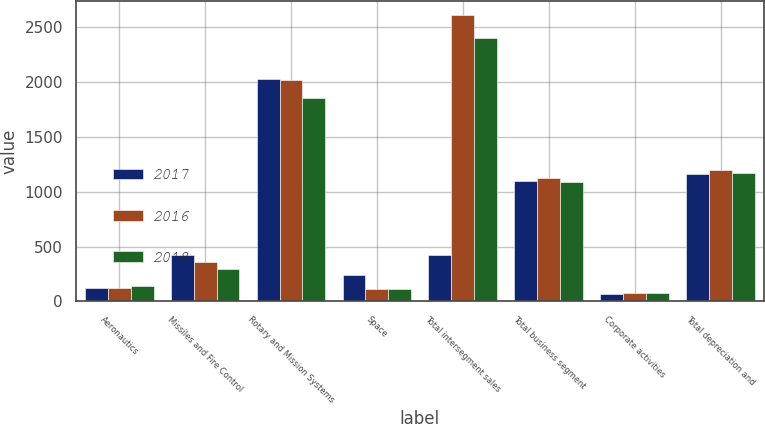Convert chart to OTSL. <chart><loc_0><loc_0><loc_500><loc_500><stacked_bar_chart><ecel><fcel>Aeronautics<fcel>Missiles and Fire Control<fcel>Rotary and Mission Systems<fcel>Space<fcel>Total intersegment sales<fcel>Total business segment<fcel>Corporate activities<fcel>Total depreciation and<nl><fcel>2017<fcel>120<fcel>423<fcel>2026<fcel>237<fcel>423<fcel>1096<fcel>65<fcel>1161<nl><fcel>2016<fcel>122<fcel>355<fcel>2020<fcel>111<fcel>2608<fcel>1123<fcel>72<fcel>1195<nl><fcel>2018<fcel>142<fcel>299<fcel>1854<fcel>110<fcel>2405<fcel>1092<fcel>75<fcel>1167<nl></chart> 